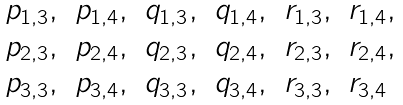<formula> <loc_0><loc_0><loc_500><loc_500>\begin{array} { l l l l l l } p _ { 1 , 3 } , & p _ { 1 , 4 } , & q _ { 1 , 3 } , & q _ { 1 , 4 } , & r _ { 1 , 3 } , & r _ { 1 , 4 } , \\ p _ { 2 , 3 } , & p _ { 2 , 4 } , & q _ { 2 , 3 } , & q _ { 2 , 4 } , & r _ { 2 , 3 } , & r _ { 2 , 4 } , \\ p _ { 3 , 3 } , & p _ { 3 , 4 } , & q _ { 3 , 3 } , & q _ { 3 , 4 } , & r _ { 3 , 3 } , & r _ { 3 , 4 } \end{array}</formula> 